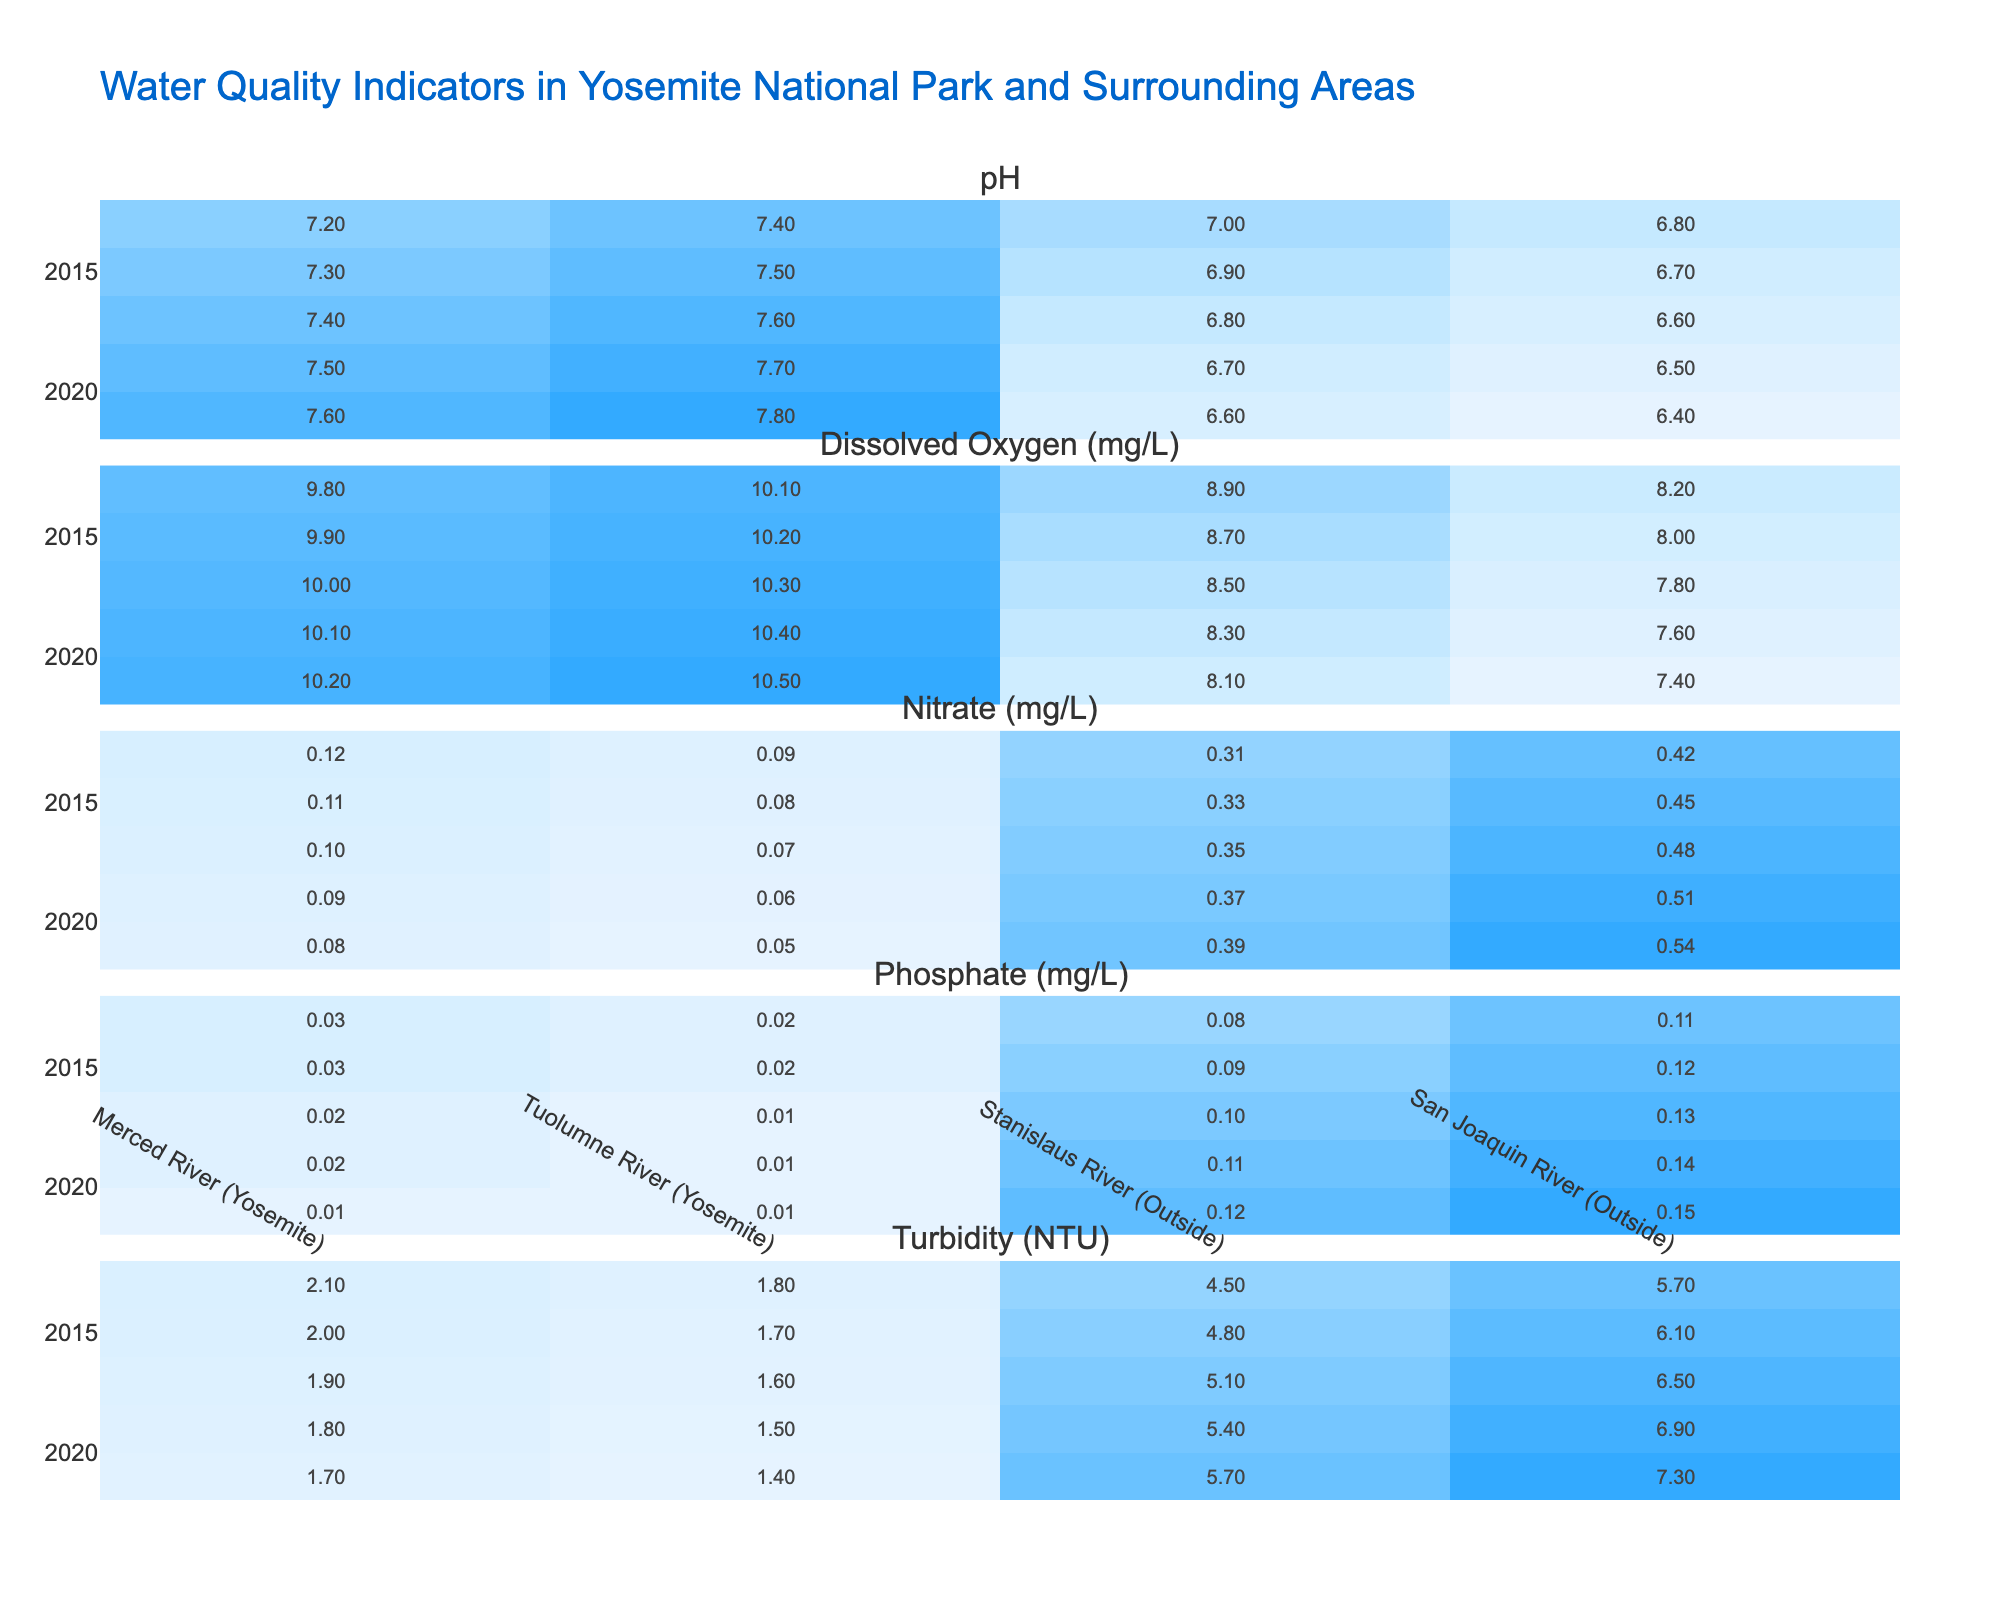What was the pH level of the Merced River in 2019? In the table, I find the row for the Merced River and the year 2019, where the pH level is listed as 7.5.
Answer: 7.5 Which river had the highest turbidity in 2015? I compare the turbidity values for each river in the year 2015 and find that the San Joaquin River had a turbidity of 6.1, which is higher than all others.
Answer: San Joaquin River What is the average dissolved oxygen level of the Tuolumne River across all years? I look at the dissolved oxygen levels for the Tuolumne River for the years presented: 10.1, 10.2, 10.3, 10.4, and 10.5. The average is calculated as (10.1 + 10.2 + 10.3 + 10.4 + 10.5) / 5 = 10.3.
Answer: 10.3 Did the phosphate levels in the Merced River increase from 2013 to 2021? I examine the phosphate levels in the Merced River for both years. In 2013, it was 0.03, and in 2021, it was 0.01, indicating a decrease.
Answer: No Which river had the lowest average nitrate level over the 10-year period? I check all nitrate levels for each river and calculate their averages. The Merced River had nitrate levels of 0.12, 0.11, 0.10, 0.09, and 0.08, averaging 0.1; Tuolumne River had 0.09, 0.08, 0.07, 0.06, and 0.05, averaging 0.07; Stanislaus River had 0.31, 0.33, 0.35, 0.37, and 0.39, averaging 0.35; San Joaquin River had 0.42, 0.45, 0.48, 0.51, and 0.54, averaging 0.48. Therefore, Tuolumne River had the lowest average.
Answer: Tuolumne River Was there any year when the turbidity level of the Stanislaus River was higher than 5 NTU? I check the turbidity levels of the Stanislaus River for each recorded year. The levels were: 4.5 (2013), 4.8 (2015), 5.1 (2017), 5.4 (2019), and 5.7 (2021). Since 2017, all measurements show turbidity levels above 5 NTU.
Answer: Yes Which location shows the most significant improvement in dissolved oxygen levels over the years? I assess the dissolved oxygen levels for all rivers over the years. Dissolved oxygen in Merced River went from 9.8 (2013) to 10.2 (2021), showing an increase. The Tuolumne River also improved from 10.1 (2013) to 10.5 (2021). In contrast, the Stanislaus and San Joaquin Rivers showed little increase and even decreases, respectively. Thus, Tuolumne River shows the most significant improvement in dissolved oxygen levels.
Answer: Tuolumne River What is the overall trend of pH levels in the Tuolumne River from 2013 to 2021? I observe the pH levels: 7.4 (2013), 7.5 (2015), 7.6 (2017), 7.7 (2019), and 7.8 (2021). Each year shows a steady increase in pH values.
Answer: Increasing trend 